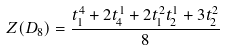Convert formula to latex. <formula><loc_0><loc_0><loc_500><loc_500>Z ( D _ { 8 } ) = \frac { t _ { 1 } ^ { 4 } + 2 t _ { 4 } ^ { 1 } + 2 t _ { 1 } ^ { 2 } t _ { 2 } ^ { 1 } + 3 t _ { 2 } ^ { 2 } } { 8 }</formula> 